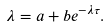<formula> <loc_0><loc_0><loc_500><loc_500>\lambda = a + b e ^ { - \lambda \tau } .</formula> 